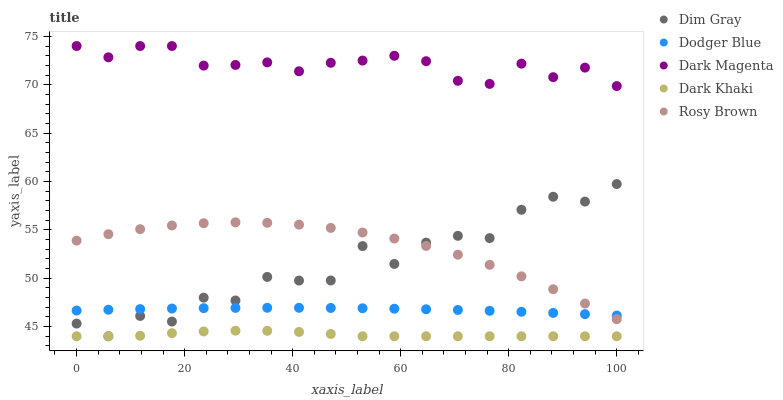Does Dark Khaki have the minimum area under the curve?
Answer yes or no. Yes. Does Dark Magenta have the maximum area under the curve?
Answer yes or no. Yes. Does Rosy Brown have the minimum area under the curve?
Answer yes or no. No. Does Rosy Brown have the maximum area under the curve?
Answer yes or no. No. Is Dodger Blue the smoothest?
Answer yes or no. Yes. Is Dim Gray the roughest?
Answer yes or no. Yes. Is Rosy Brown the smoothest?
Answer yes or no. No. Is Rosy Brown the roughest?
Answer yes or no. No. Does Dark Khaki have the lowest value?
Answer yes or no. Yes. Does Rosy Brown have the lowest value?
Answer yes or no. No. Does Dark Magenta have the highest value?
Answer yes or no. Yes. Does Rosy Brown have the highest value?
Answer yes or no. No. Is Dark Khaki less than Dark Magenta?
Answer yes or no. Yes. Is Dodger Blue greater than Dark Khaki?
Answer yes or no. Yes. Does Rosy Brown intersect Dim Gray?
Answer yes or no. Yes. Is Rosy Brown less than Dim Gray?
Answer yes or no. No. Is Rosy Brown greater than Dim Gray?
Answer yes or no. No. Does Dark Khaki intersect Dark Magenta?
Answer yes or no. No. 